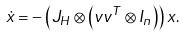<formula> <loc_0><loc_0><loc_500><loc_500>\dot { x } = & - \left ( J _ { H } \otimes \left ( v v ^ { T } \otimes I _ { n } \right ) \right ) x .</formula> 